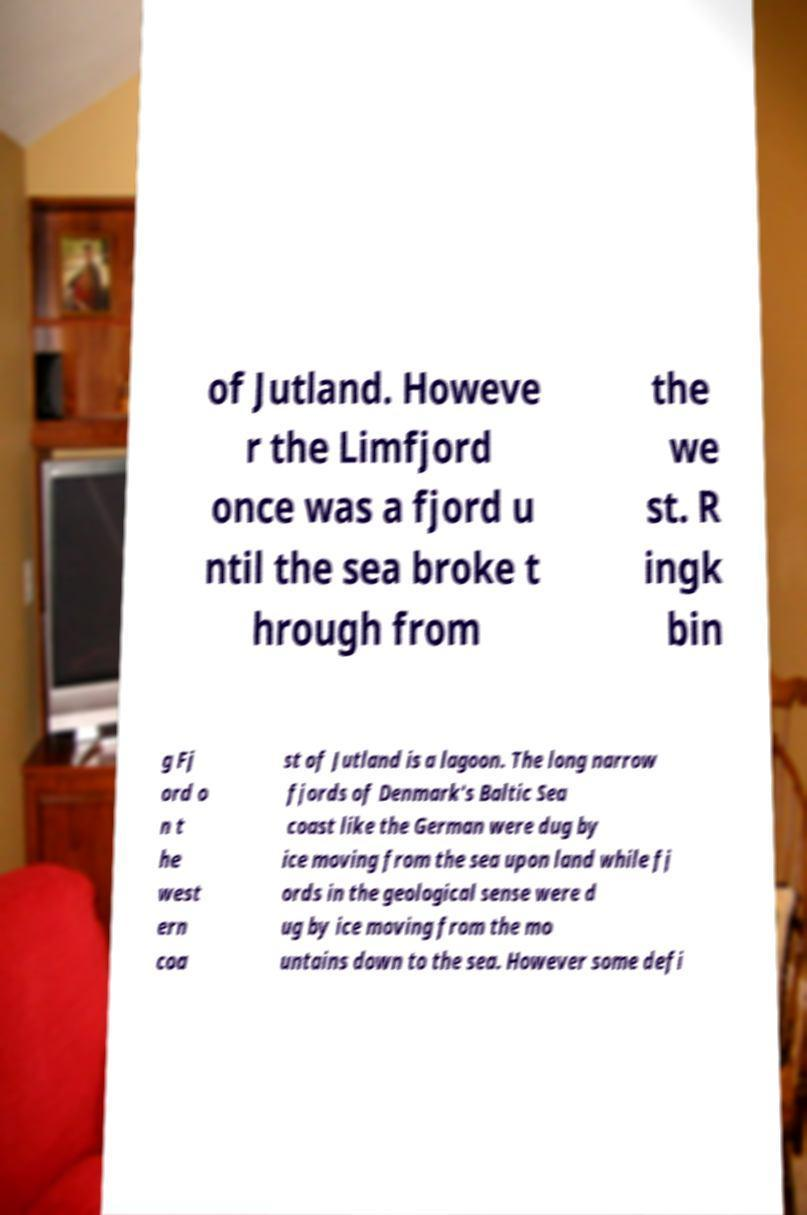There's text embedded in this image that I need extracted. Can you transcribe it verbatim? of Jutland. Howeve r the Limfjord once was a fjord u ntil the sea broke t hrough from the we st. R ingk bin g Fj ord o n t he west ern coa st of Jutland is a lagoon. The long narrow fjords of Denmark's Baltic Sea coast like the German were dug by ice moving from the sea upon land while fj ords in the geological sense were d ug by ice moving from the mo untains down to the sea. However some defi 